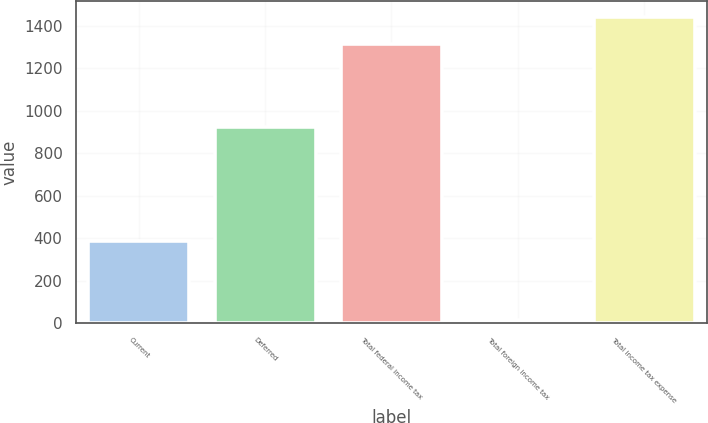<chart> <loc_0><loc_0><loc_500><loc_500><bar_chart><fcel>Current<fcel>Deferred<fcel>Total federal income tax<fcel>Total foreign income tax<fcel>Total income tax expense<nl><fcel>387<fcel>925<fcel>1312<fcel>15<fcel>1443.2<nl></chart> 